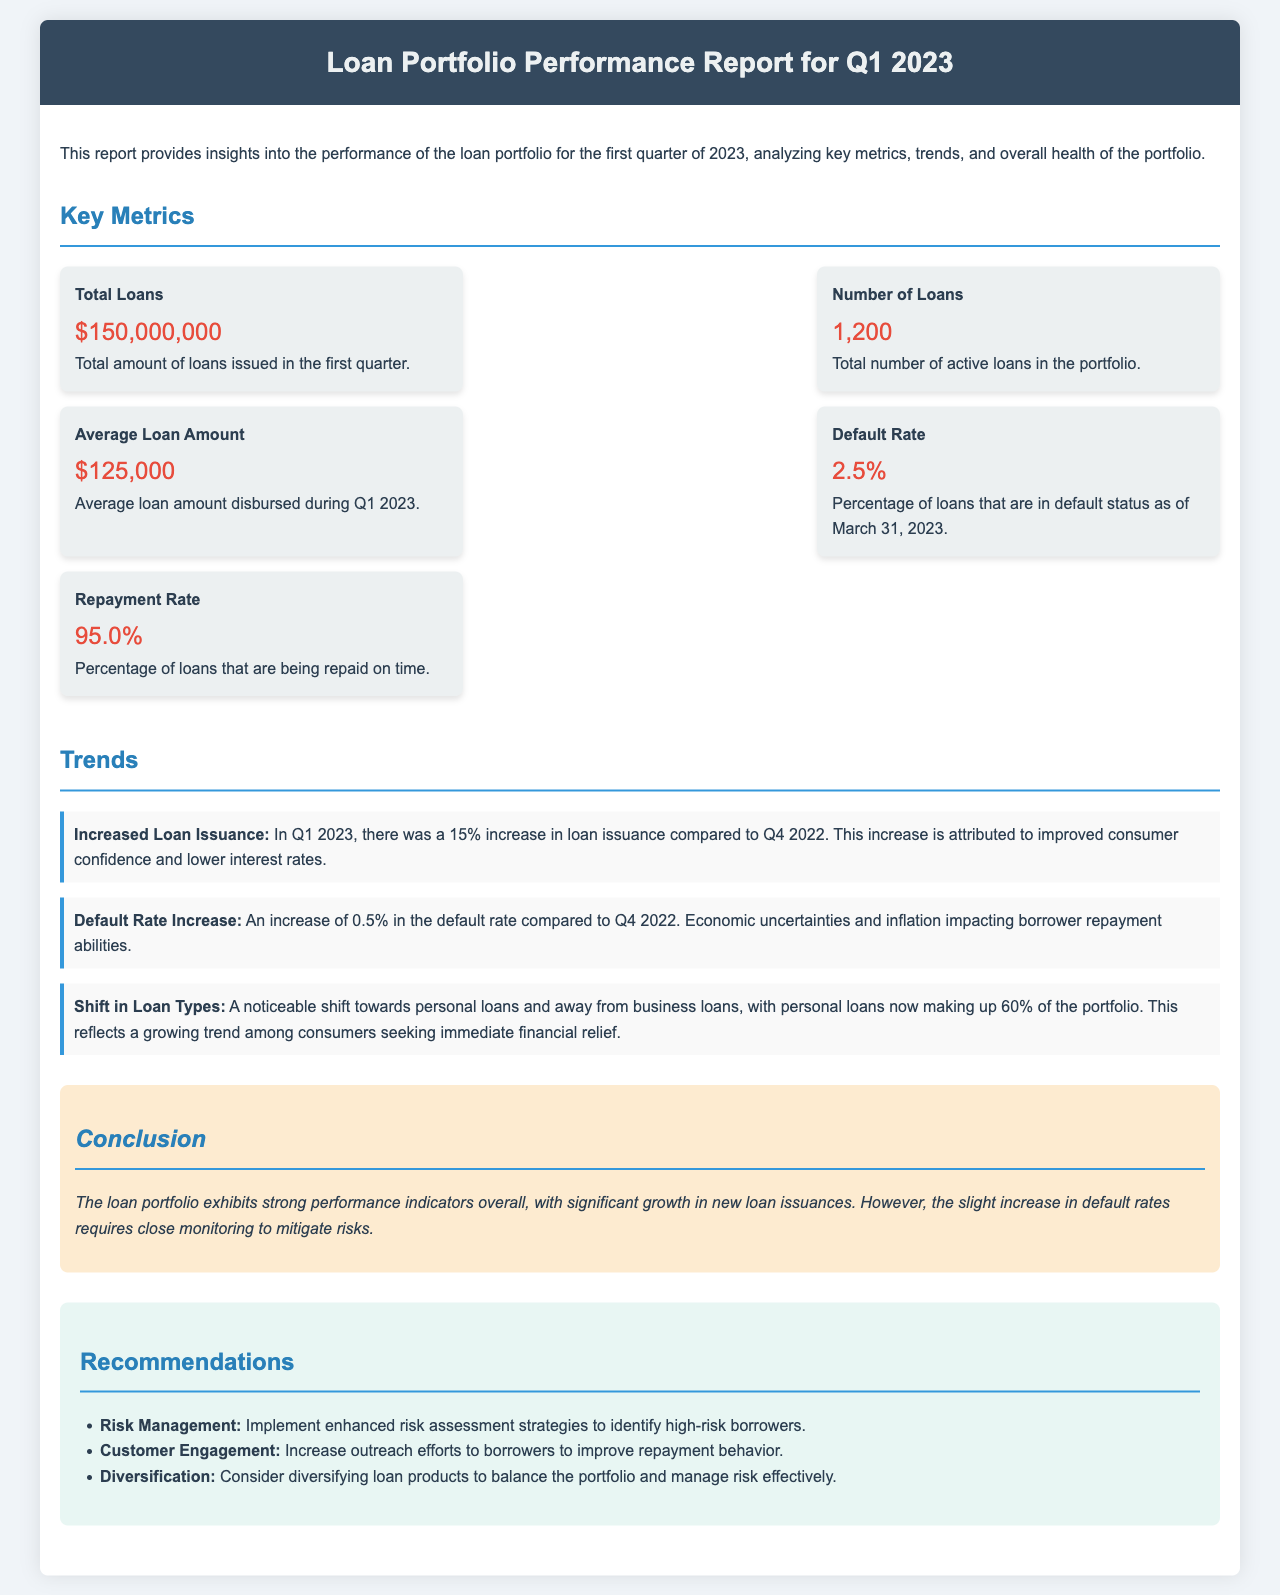What is the total amount of loans issued? The total loans metric provides the sum of loans issued in the first quarter, which is indicated in the report.
Answer: $150,000,000 How many active loans are in the portfolio? The number of loans metric shows the total number of active loans at the end of Q1 2023.
Answer: 1,200 What is the average loan amount disbursed during Q1 2023? The average loan amount is calculated by dividing total loans by the number of loans, which is provided in the metrics section.
Answer: $125,000 What was the default rate as of March 31, 2023? The report specifies the percentage of loans in default status at the end of the quarter.
Answer: 2.5% What is the repayment rate for the loans? The repayment rate metric indicates the percentage of loans that are being repaid on time.
Answer: 95.0% What was the increase in loan issuance compared to Q4 2022? The report discusses the percentage increase in loan issuance as compared to the previous quarter.
Answer: 15% Which type of loans now makes up 60% of the portfolio? The report states the shift in loan types, specifying which type has become predominant.
Answer: Personal loans What is the main concern highlighted in the conclusion? The conclusion summarizes the overall performance, including the concern regarding default rates.
Answer: Slight increase in default rates What recommendation is given for risk management? The recommendations section provides specific strategies to mitigate risks associated with borrower default.
Answer: Implement enhanced risk assessment strategies 